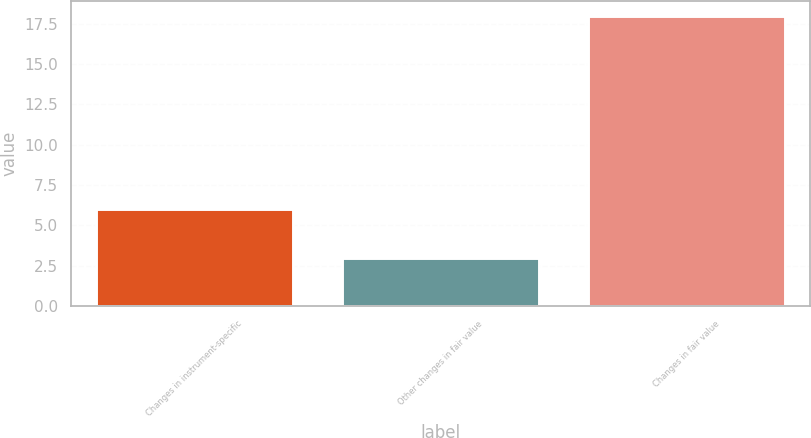Convert chart. <chart><loc_0><loc_0><loc_500><loc_500><bar_chart><fcel>Changes in instrument-specific<fcel>Other changes in fair value<fcel>Changes in fair value<nl><fcel>6<fcel>3<fcel>18<nl></chart> 